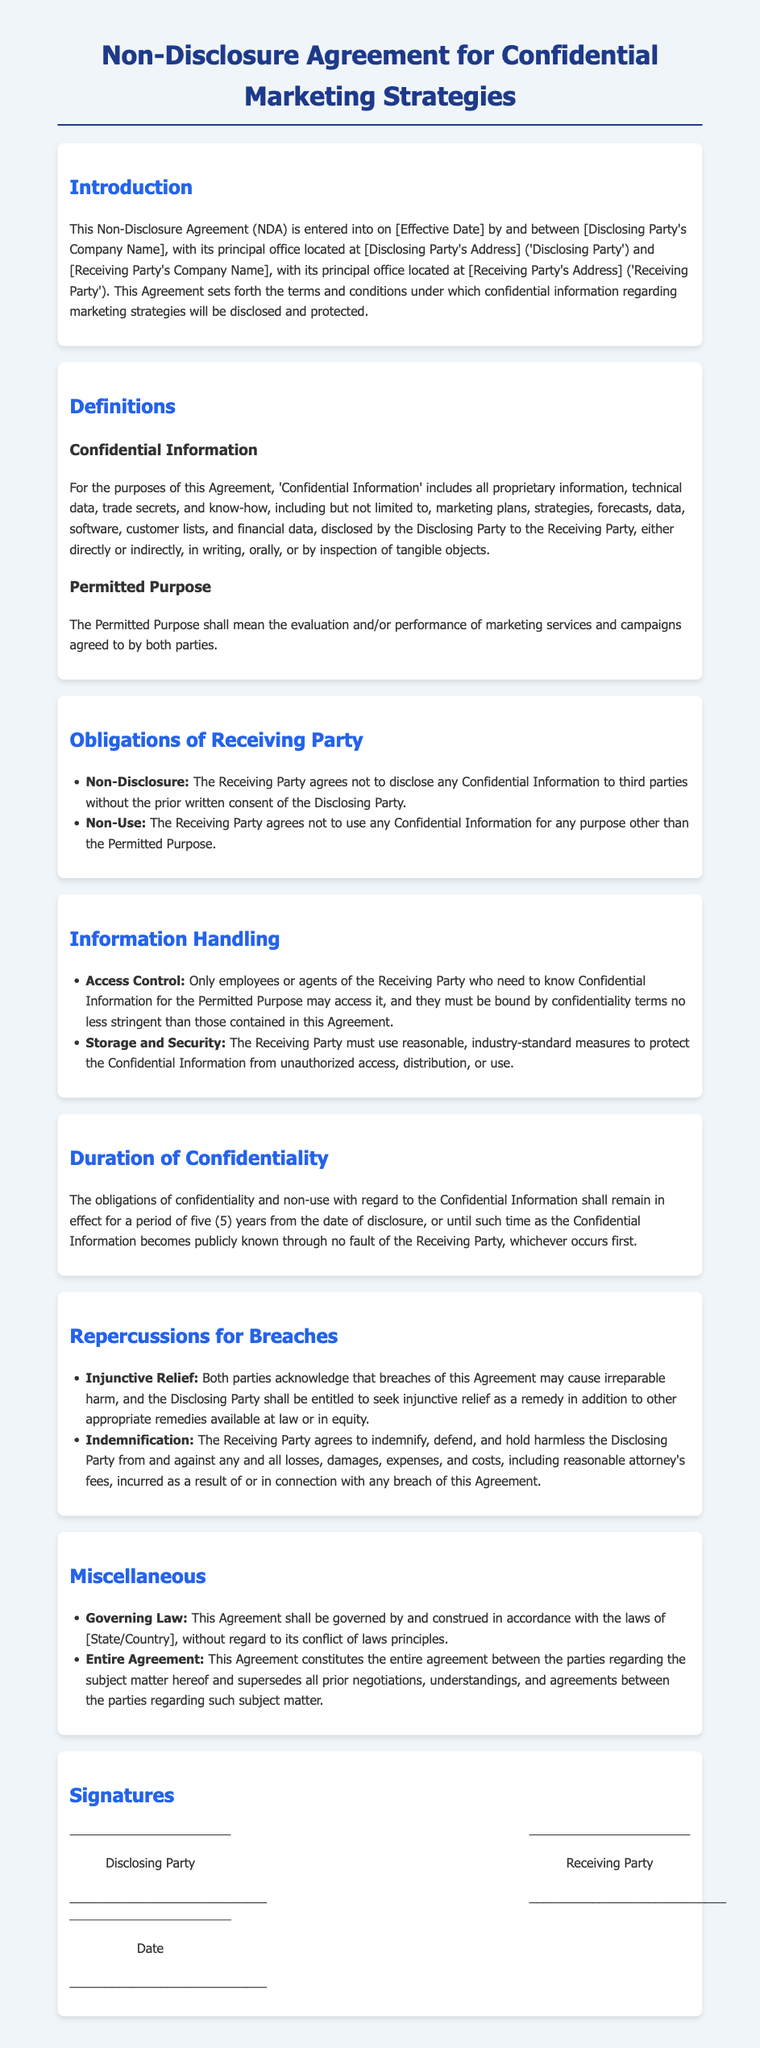What is the effective duration of confidentiality? The duration of confidentiality is specified in the document as five (5) years.
Answer: five (5) years What parties are involved in the NDA? The document specifies the Disclosing Party and the Receiving Party but does not provide their names in the questionnaire.
Answer: Disclosing Party and Receiving Party What type of relief can the Disclosing Party seek in case of a breach? The document states that the Disclosing Party can seek injunctive relief.
Answer: injunctive relief What is Confidential Information? The document defines Confidential Information as all proprietary information, technical data, trade secrets, and know-how, including marketing plans, strategies, forecasts, etc.
Answer: proprietary information, technical data, trade secrets, and know-how Who is responsible for handling Confidential Information in the Receiving Party? The document specifies that only employees or agents of the Receiving Party who need to know may access the Confidential Information.
Answer: employees or agents of the Receiving Party What does the Receiving Party agree regarding the use of Confidential Information? The Receiving Party agrees not to use any Confidential Information for purposes other than the Permitted Purpose.
Answer: not to use for any purpose other than the Permitted Purpose Under which law is this NDA governed? The document states that the NDA shall be governed by the laws of a specific State or Country, which is yet to be filled.
Answer: [State/Country] What is the consequence for breaches of the NDA? The document states that the Receiving Party agrees to indemnify, defend, and hold harmless the Disclosing Party for any losses incurred as a result of a breach.
Answer: indemnify, defend, and hold harmless 